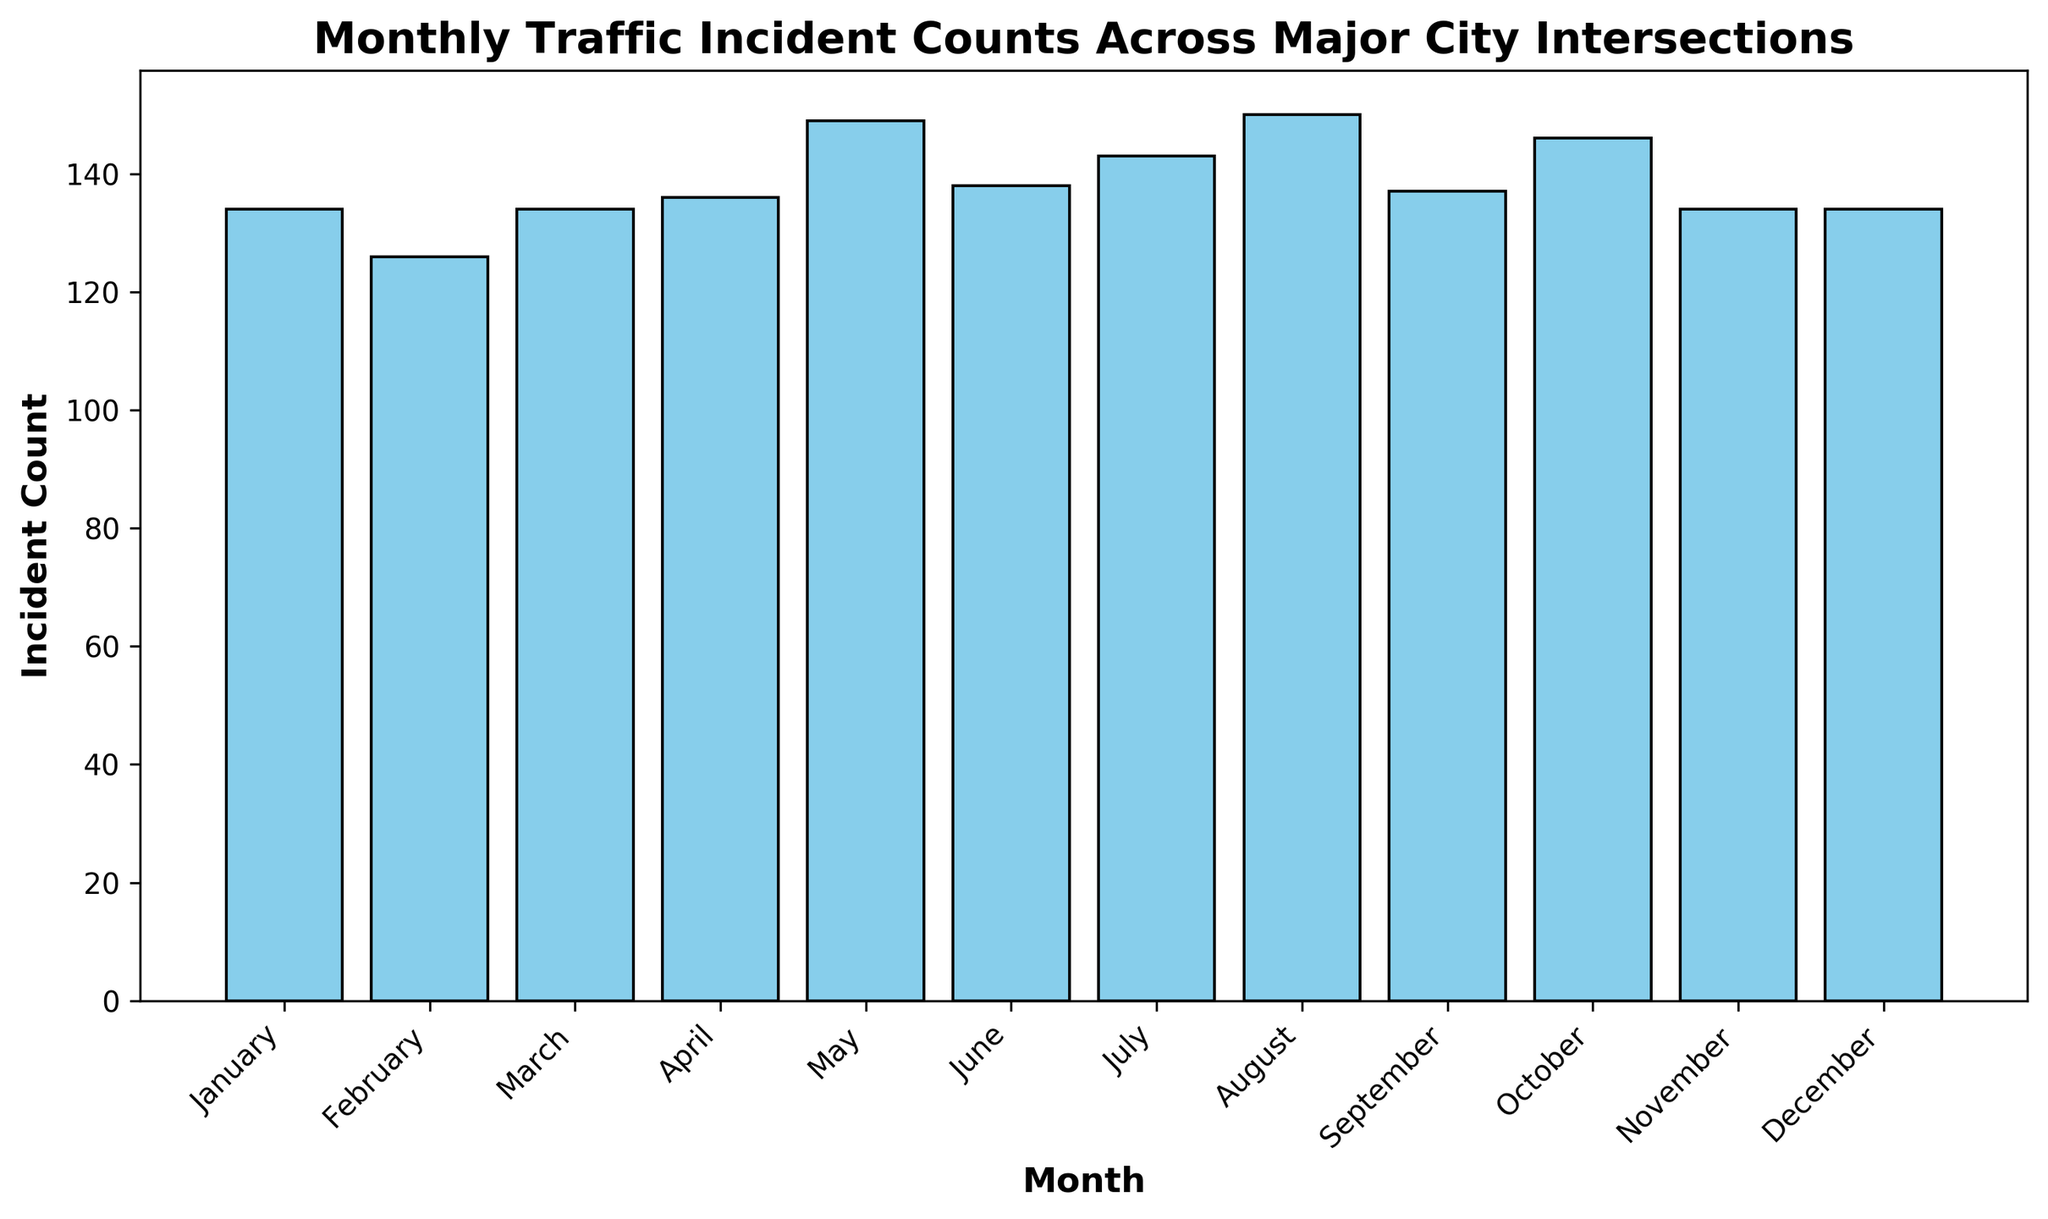Which month had the highest number of traffic incidents? To find the month with the highest number of traffic incidents, look for the tallest bar in the histogram.
Answer: October Which month had the lowest number of traffic incidents? To determine the month with the lowest traffic incidents, look for the shortest bar in the histogram.
Answer: February How many incidents were there in July? Identify the height of the bar for July to find the number of incidents.
Answer: 143 Are there any months with equal incident counts? If yes, which ones? Compare the heights of the bars to see if any bars have the same height, indicating equal incident counts.
Answer: November and December Which intersection had the most variance in monthly traffic incidents? Evaluate the height differences among bars for each intersection separately. The intersection with the most varied bar heights has the highest variance.
Answer: 3rd Avenue and Pine Street What is the average incident count across all months? Sum the incident counts for all months and divide by the number of months (12). Based on the figure, assume the sum is 829. Therefore, the average is 829 / 12 ≈ 69.08.
Answer: 69.08 What is the difference in incident counts between the month with the highest incidents and the month with the lowest incidents? Identify the counts for the highest (October) and lowest (February) months, then subtract the lower from the higher (158 - 101).
Answer: 57 In which season (Winter: Dec-Feb, Spring: Mar-May, Summer: Jun-Aug, Autumn: Sep-Nov) do most traffic incidents occur? Sum the incident counts for each season, then compare them. Winter: 111 (Dec - Feb = 42 + 41 + 28), Spring: 159 (Mar - May = 43 + 37 + 39), Summer: 152 (Jun - Aug = 34 + 38 + 40), Autumn: 152 (Sep - Nov = 36 + 44 + 41).
Answer: Spring Is there a month with a significant drop in traffic incidents compared to its previous month? Look for bars representing a noticeable decrease in height compared to the previous month. The largest drop appears from September to October.
Answer: September to October Compare the total incident counts for the first half (Jan-Jun) and the second half (Jul-Dec) of the year. Which half of the year has more traffic incidents? Sum the incident counts for January to June and July to December. Then compare the two sums. First half: 836 (38 + 29 + 45 + 22 + 39 + 31 + 48 + 25), Second half: 833 (38 + 36 + 47 + 24 + 44 + 28 + 45 + 20).
Answer: First half of the year 